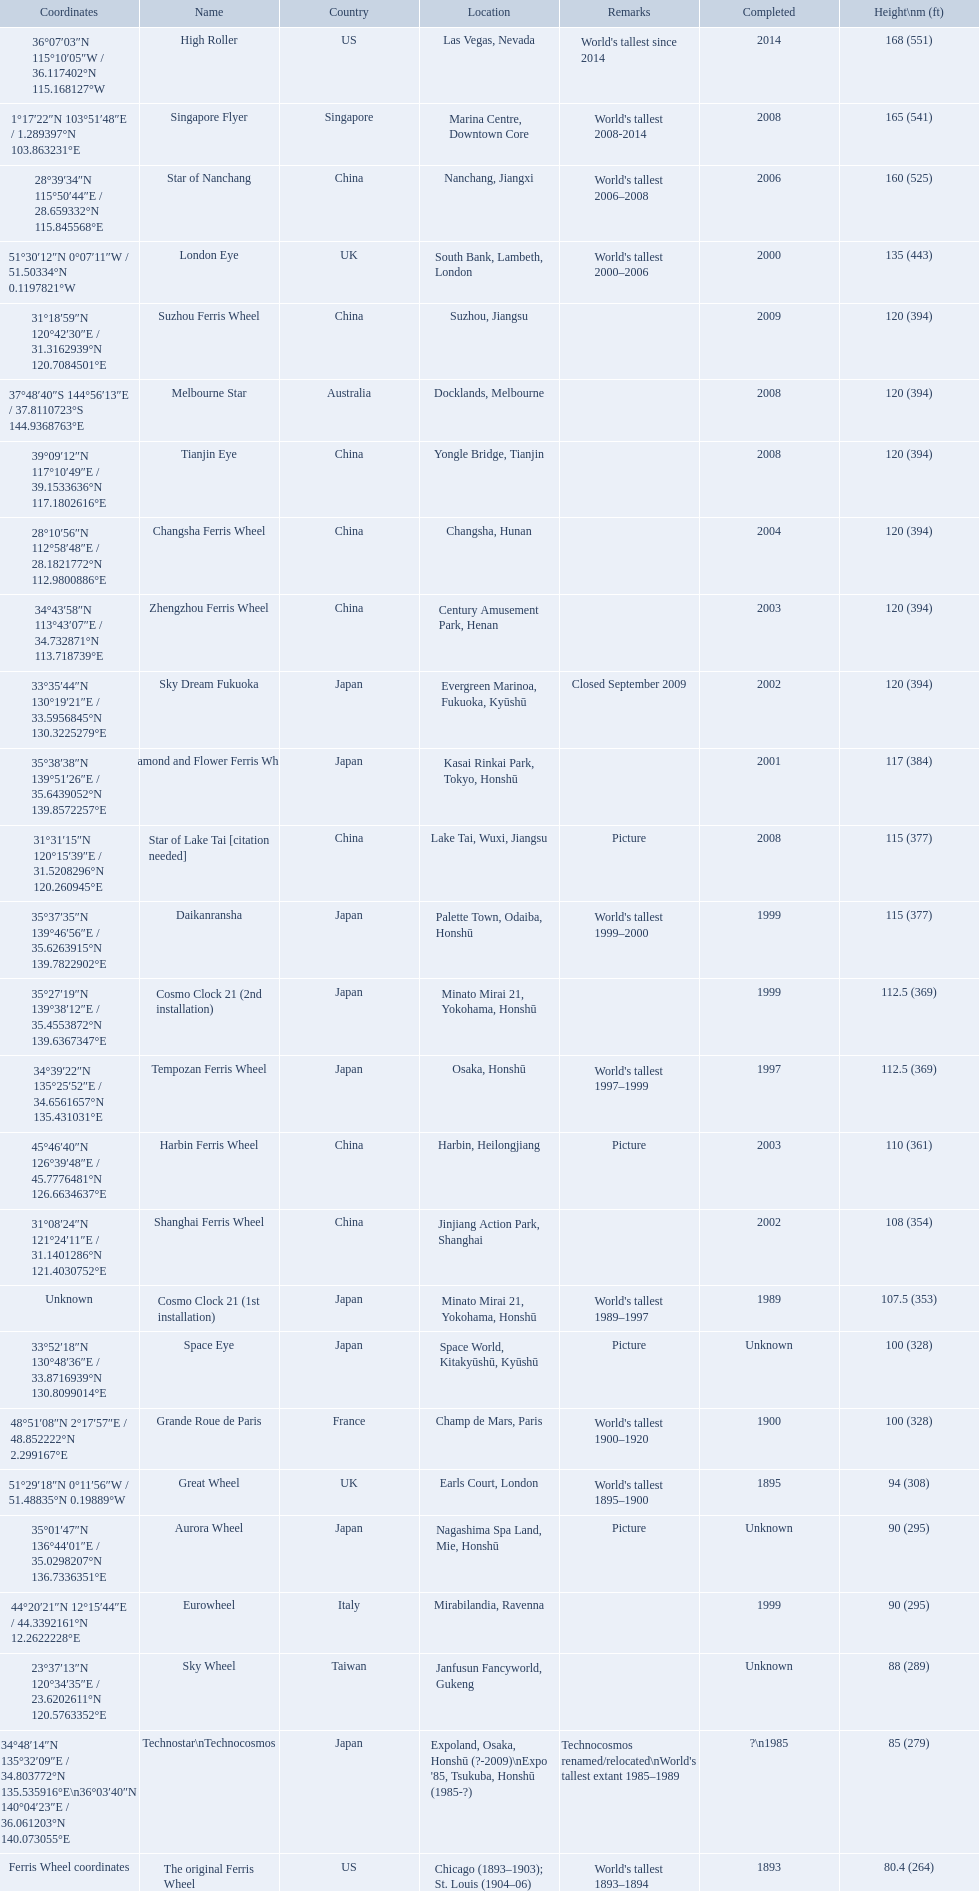What ferris wheels were completed in 2008 Singapore Flyer, Melbourne Star, Tianjin Eye, Star of Lake Tai [citation needed]. Of these, which has the height of 165? Singapore Flyer. What are all of the ferris wheels? High Roller, Singapore Flyer, Star of Nanchang, London Eye, Suzhou Ferris Wheel, Melbourne Star, Tianjin Eye, Changsha Ferris Wheel, Zhengzhou Ferris Wheel, Sky Dream Fukuoka, Diamond and Flower Ferris Wheel, Star of Lake Tai [citation needed], Daikanransha, Cosmo Clock 21 (2nd installation), Tempozan Ferris Wheel, Harbin Ferris Wheel, Shanghai Ferris Wheel, Cosmo Clock 21 (1st installation), Space Eye, Grande Roue de Paris, Great Wheel, Aurora Wheel, Eurowheel, Sky Wheel, Technostar\nTechnocosmos, The original Ferris Wheel. And when were they completed? 2014, 2008, 2006, 2000, 2009, 2008, 2008, 2004, 2003, 2002, 2001, 2008, 1999, 1999, 1997, 2003, 2002, 1989, Unknown, 1900, 1895, Unknown, 1999, Unknown, ?\n1985, 1893. And among star of lake tai, star of nanchang, and melbourne star, which ferris wheel is oldest? Star of Nanchang. 